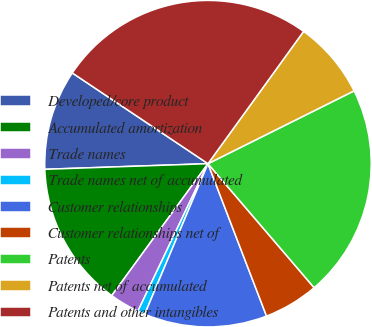Convert chart. <chart><loc_0><loc_0><loc_500><loc_500><pie_chart><fcel>Developed/core product<fcel>Accumulated amortization<fcel>Trade names<fcel>Trade names net of accumulated<fcel>Customer relationships<fcel>Customer relationships net of<fcel>Patents<fcel>Patents net of accumulated<fcel>Patents and other intangibles<nl><fcel>9.93%<fcel>14.42%<fcel>2.97%<fcel>0.73%<fcel>12.17%<fcel>5.43%<fcel>21.09%<fcel>7.68%<fcel>25.58%<nl></chart> 